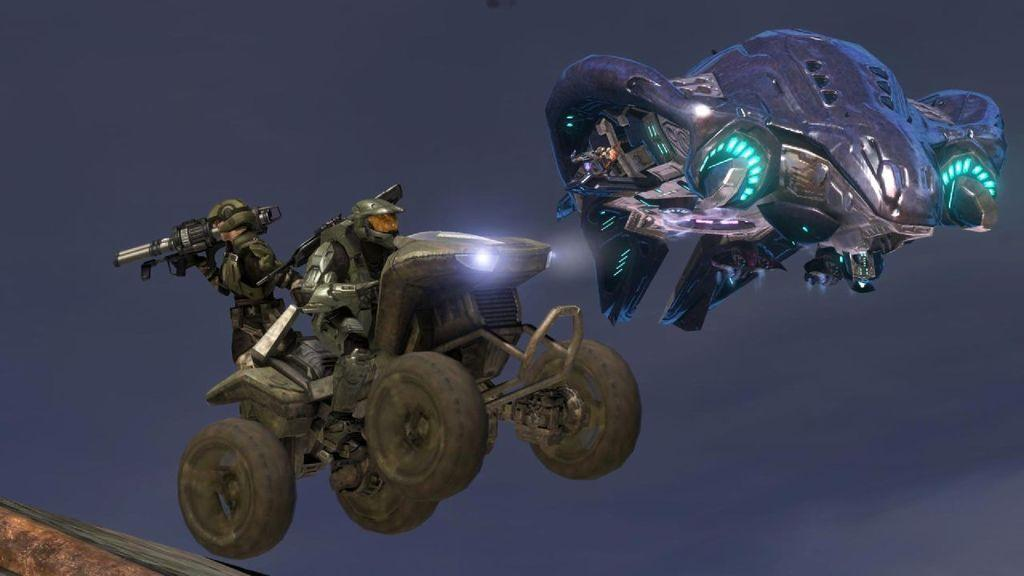What type of vehicles are flying in the image? There are two animated flying vehicles in the image. What other type of vehicle can be seen in the image? There is a person on a jet ski vehicle in the image. What is the person holding in the image? The person is holding a bioscope in the image. What statement does the person holding the bioscope make in the image? There is no statement being made by the person holding the bioscope in the image. 